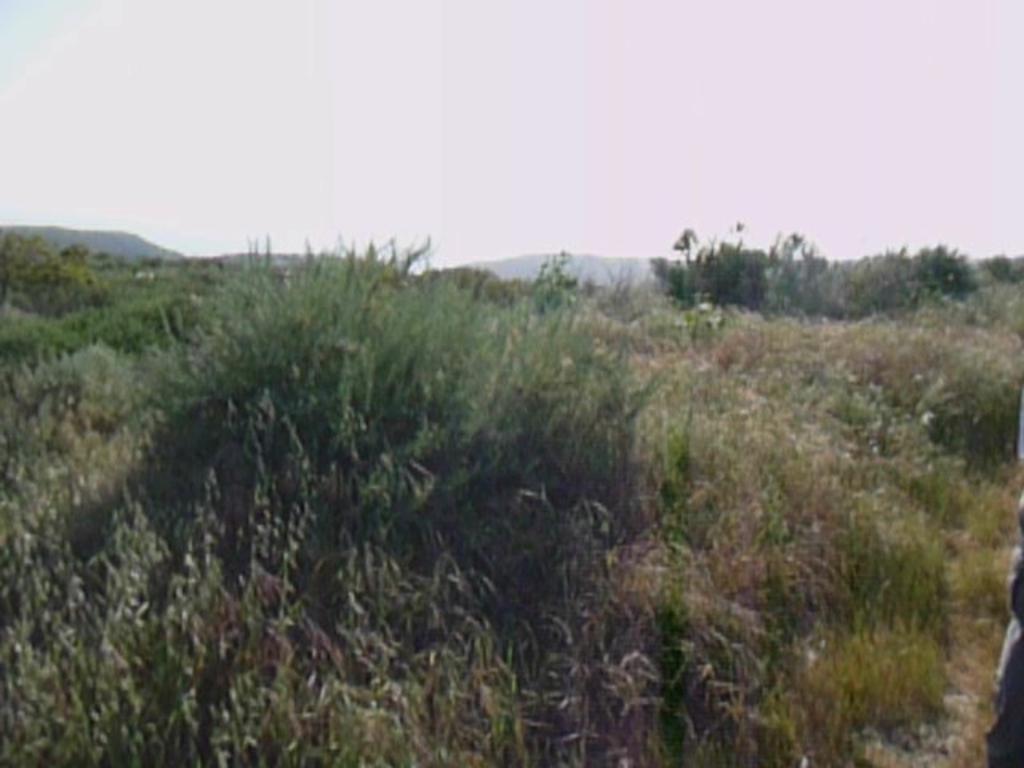How would you summarize this image in a sentence or two? In this image I can see few green grass and mountains. The sky is in blue and white color. 